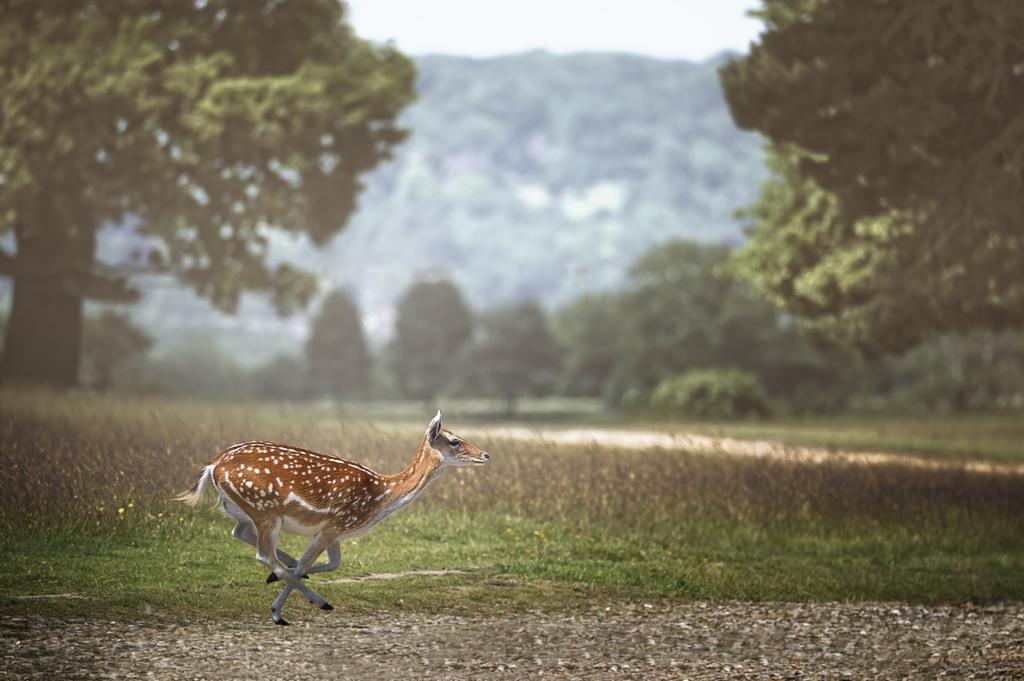What animal is present in the image? There is a deer in the image. What can be seen behind the deer? There are plants behind the deer. What type of vegetation covers the land in the image? The land is full of grass. What color of paint is the deer covered in? The deer is not covered in paint; it is a natural animal in its natural environment. 